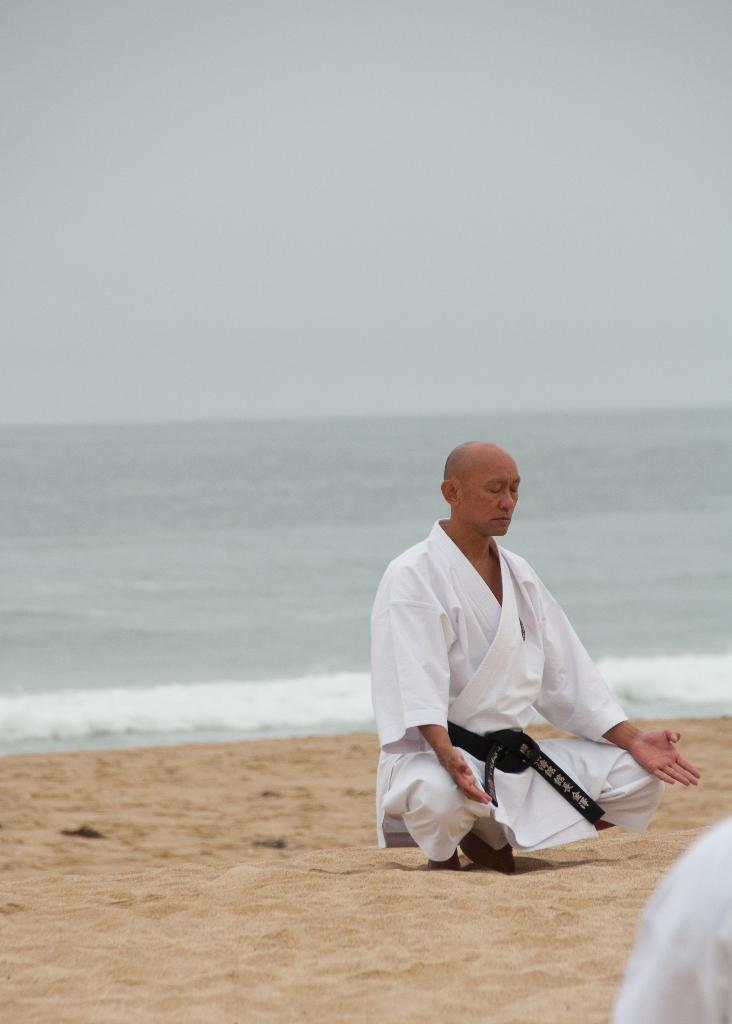Describe this image in one or two sentences. This image is taken outdoors. At the bottom of the image there is a ground. In the background there is a sea with waves. In the middle of the image a man is doing yoga on the ground. 